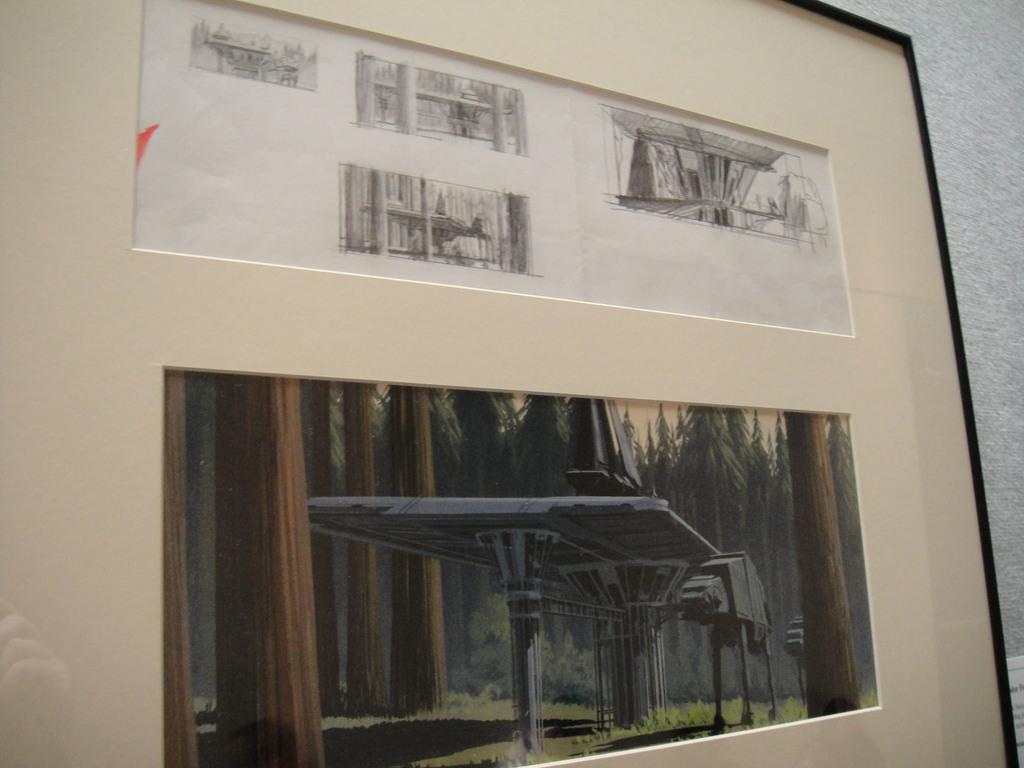What is hanging on the wall in the image? There is a photo frame on the wall. What is inside the photo frame? The photo frame contains paintings. Can you describe the drawing in the image? There is a drawing with a machine depicted. What type of natural environment is visible in the image? There is grass on the ground and trees present. What type of cord is used to hang the painting in the image? There is no cord visible in the image, as the painting is contained within a photo frame that is hanging on the wall. How many hens can be seen in the image? There are no hens present in the image. 